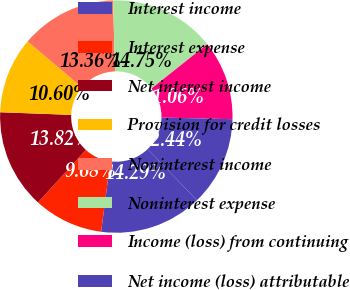Convert chart. <chart><loc_0><loc_0><loc_500><loc_500><pie_chart><fcel>Interest income<fcel>Interest expense<fcel>Net interest income<fcel>Provision for credit losses<fcel>Noninterest income<fcel>Noninterest expense<fcel>Income (loss) from continuing<fcel>Net income (loss) attributable<nl><fcel>14.29%<fcel>9.68%<fcel>13.82%<fcel>10.6%<fcel>13.36%<fcel>14.75%<fcel>11.06%<fcel>12.44%<nl></chart> 